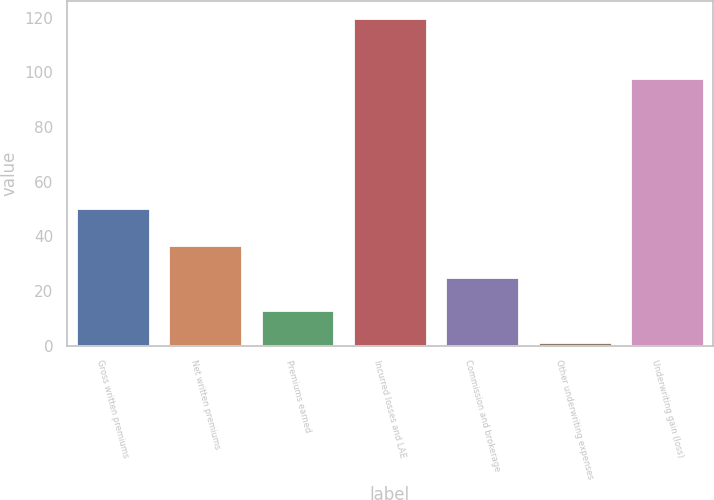Convert chart to OTSL. <chart><loc_0><loc_0><loc_500><loc_500><bar_chart><fcel>Gross written premiums<fcel>Net written premiums<fcel>Premiums earned<fcel>Incurred losses and LAE<fcel>Commission and brokerage<fcel>Other underwriting expenses<fcel>Underwriting gain (loss)<nl><fcel>50.4<fcel>36.91<fcel>13.17<fcel>120<fcel>25.04<fcel>1.3<fcel>98.1<nl></chart> 